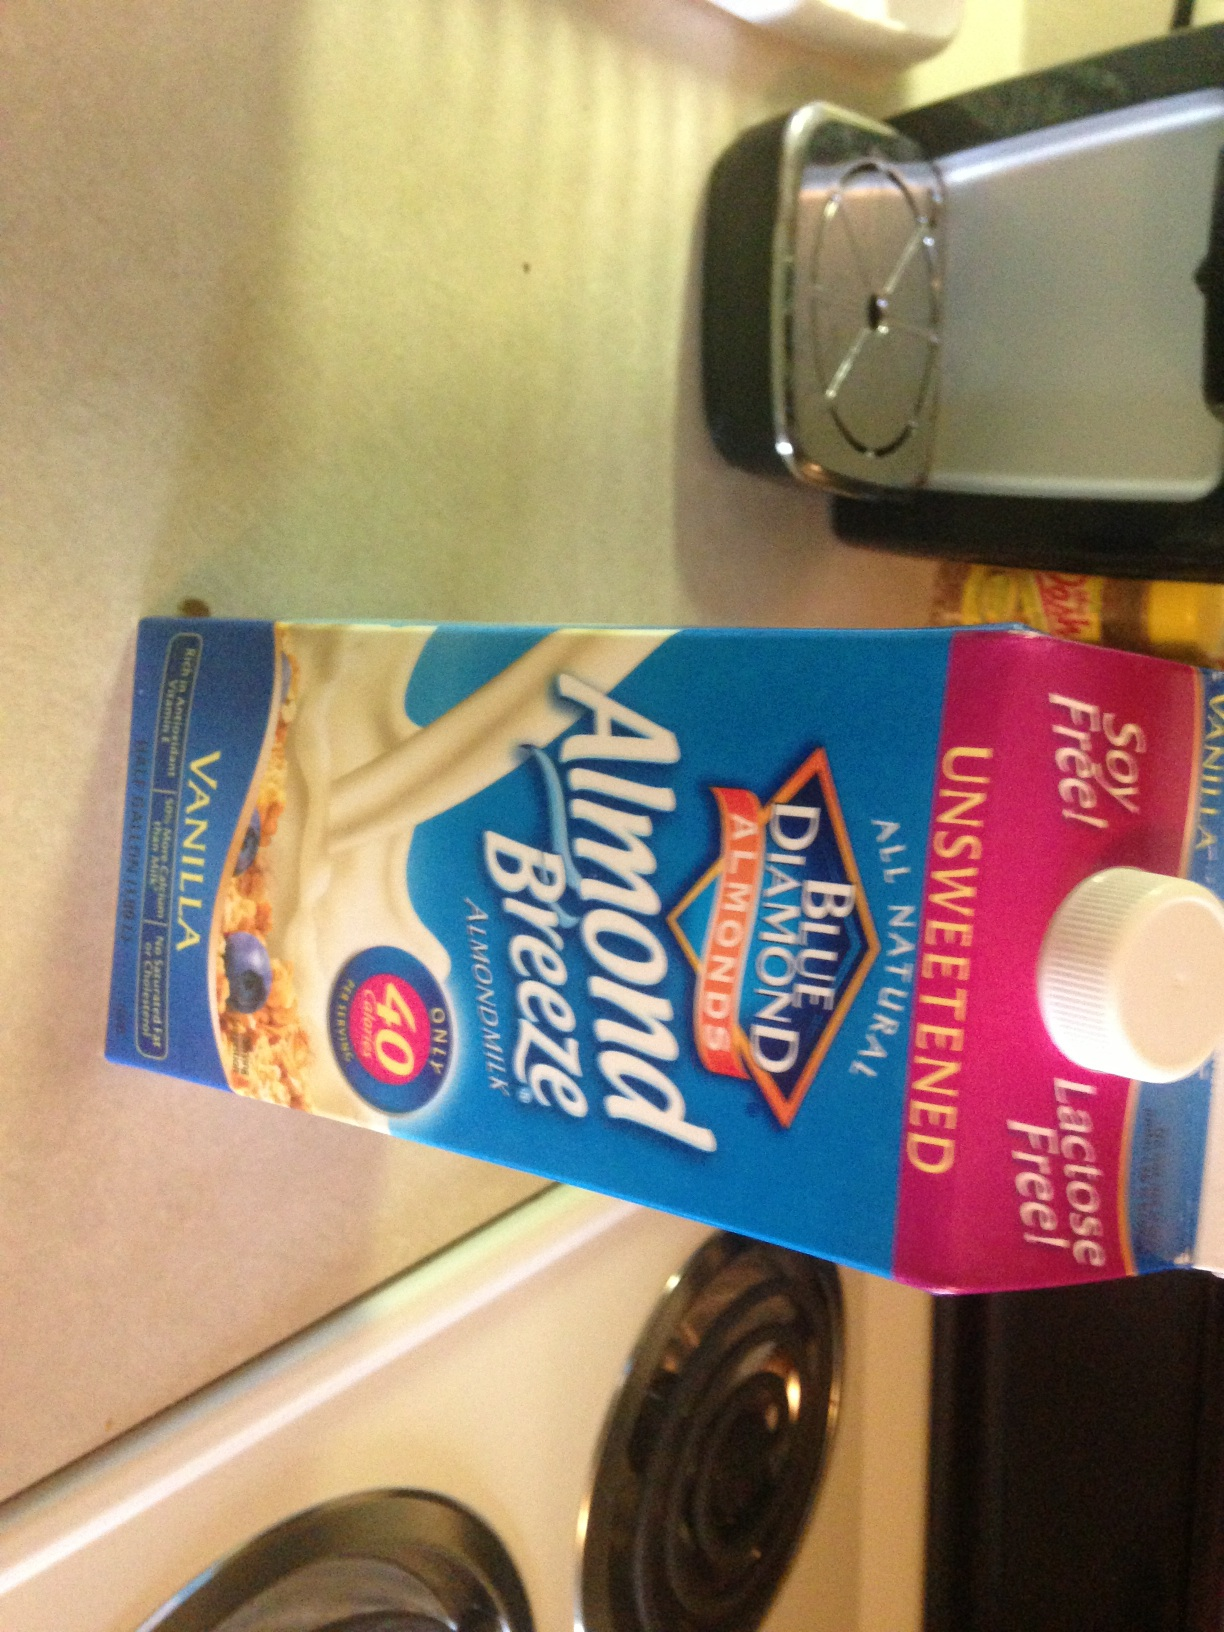What is the date on this milk? Unfortunately, the date on the milk carton is not visible in the provided image. To find the expiration date, please check the top or sides of the carton directly. Expiration dates are typically printed in a format that includes the month, day, and year. 